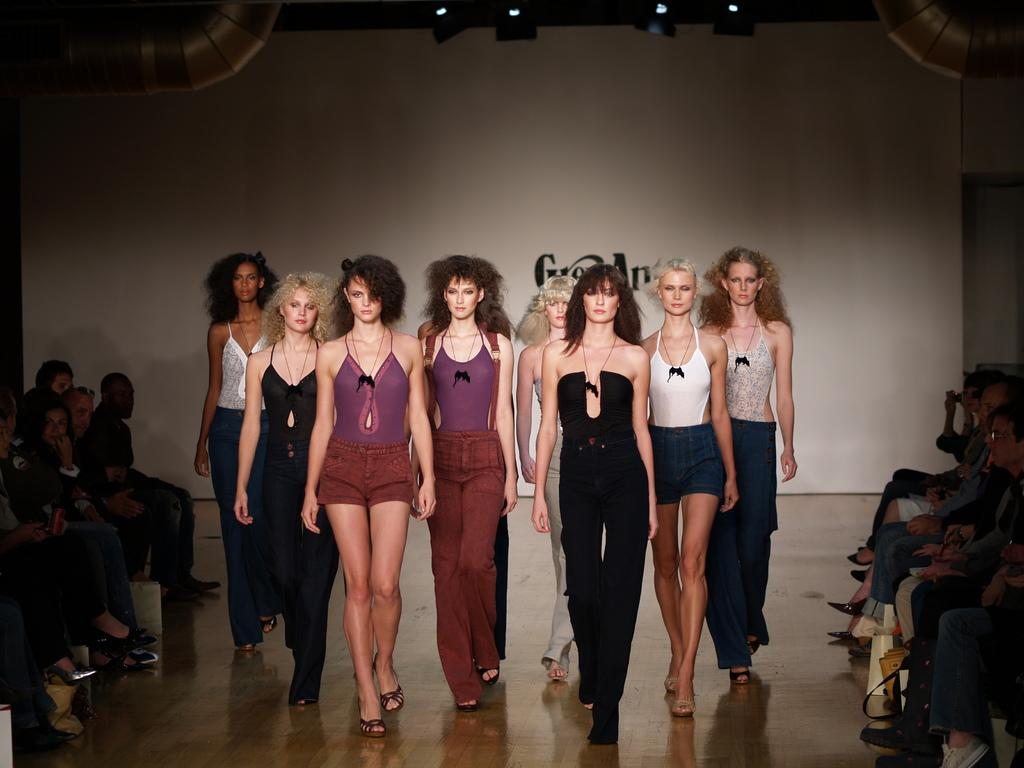What are the people in the image doing? There are people walking and sitting in the image. What can be seen illuminating the area in the image? There are lights visible in the image. What is present on the top of the image? There are pipes on the top of the image. What is in the background of the image? There is a banner in the background of the image. How many eyes can be seen on the people in the image? The number of eyes cannot be determined from the image, as faces are not clearly visible. 